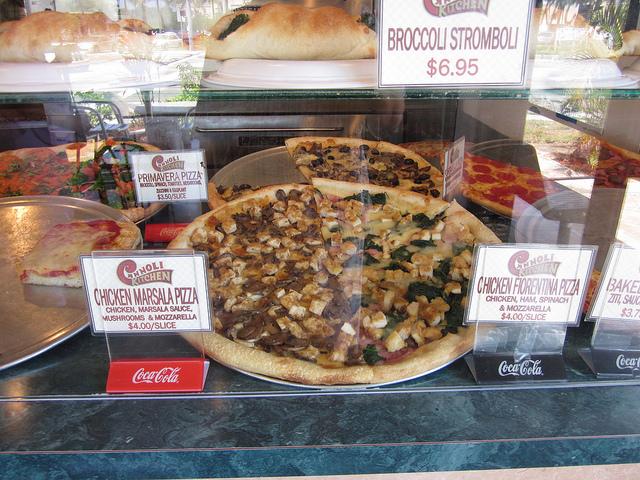How much is the broccoli Stromboli?
Be succinct. $6.95. Is this a Chinese style restaurant?
Keep it brief. No. What drink is being advertised?
Answer briefly. Coca cola. 